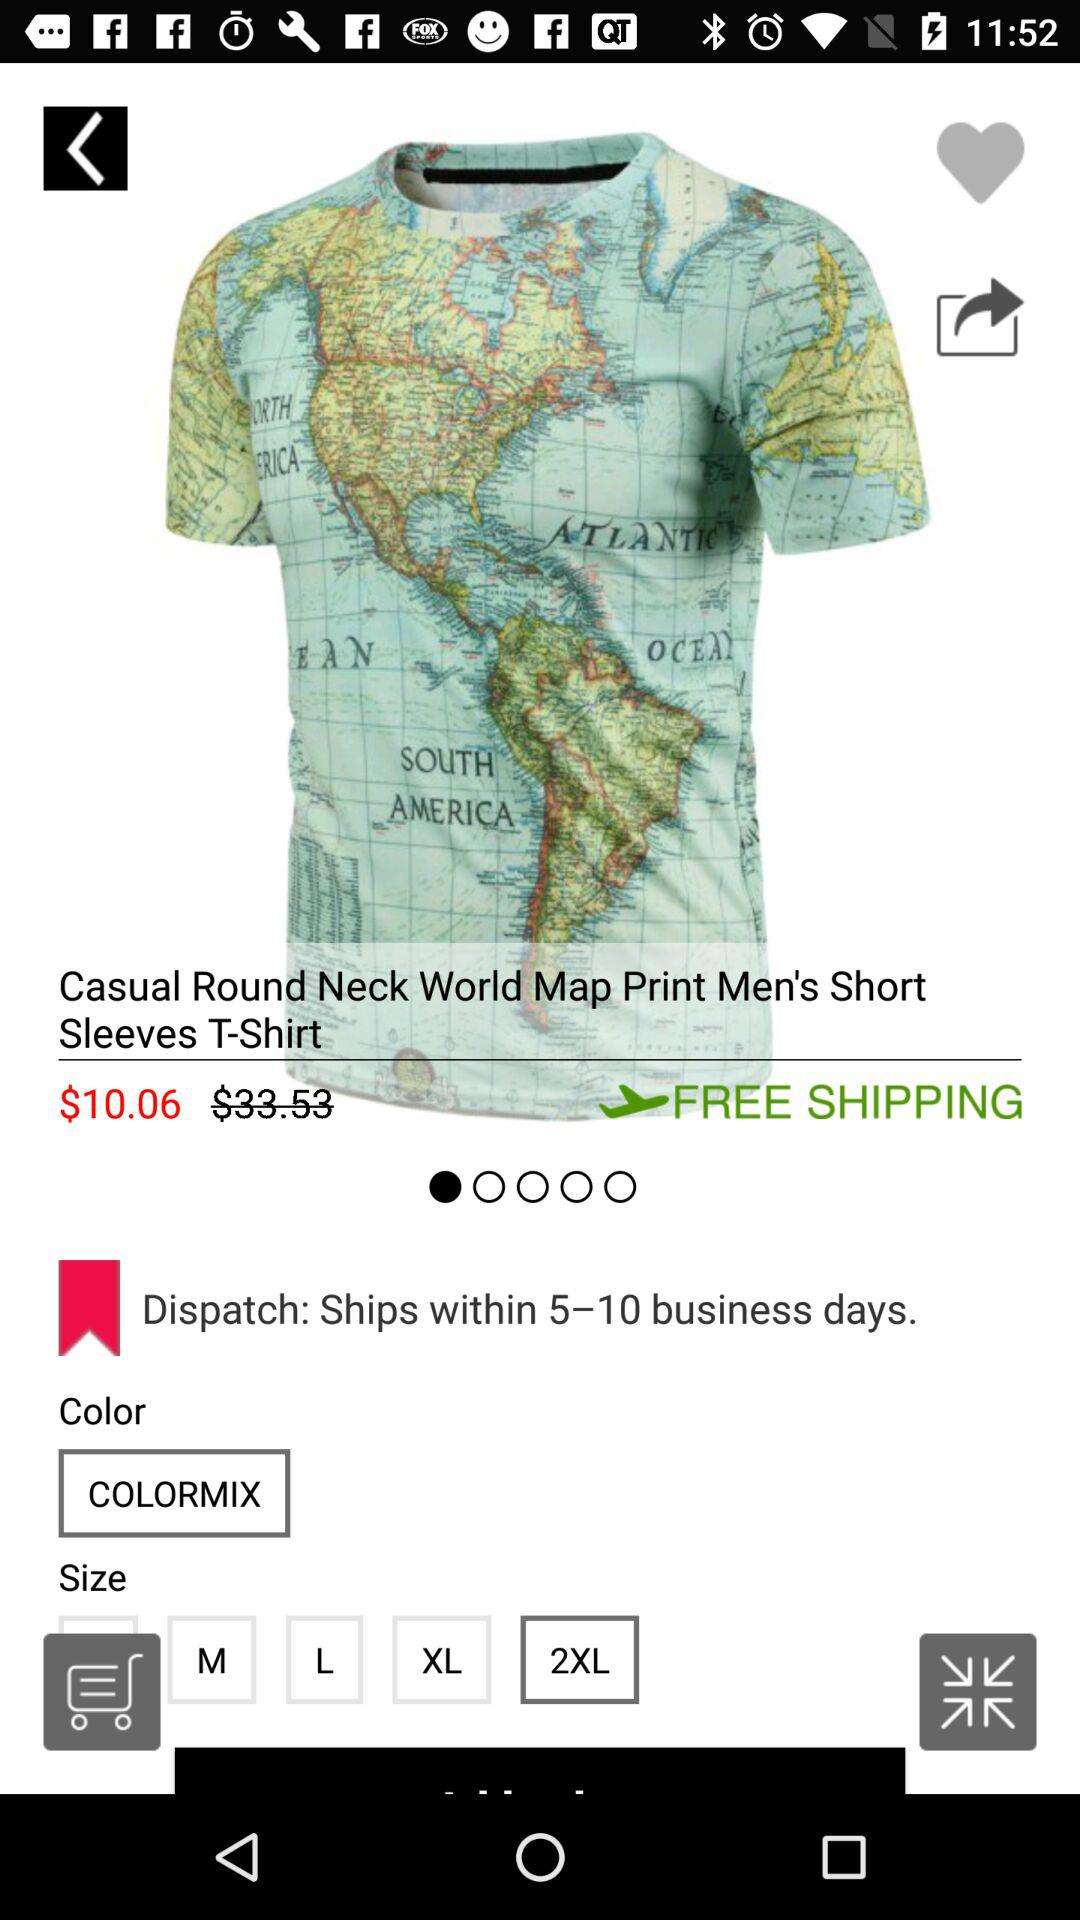What is the price of the T-Shirt? The price of the T-Shirt is $10.06. 